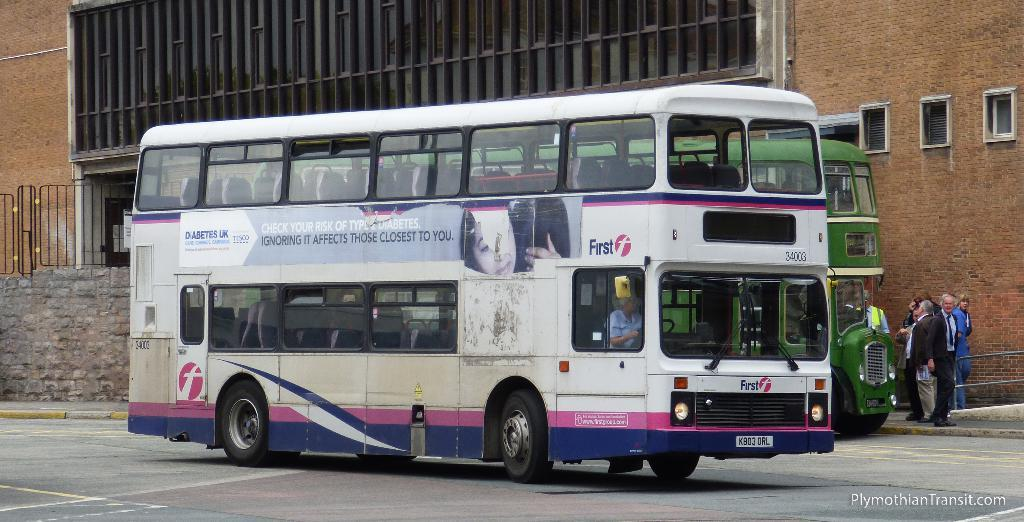Provide a one-sentence caption for the provided image. Double decker bus #34003 has an advertisement for Diabetes UK on the side. 